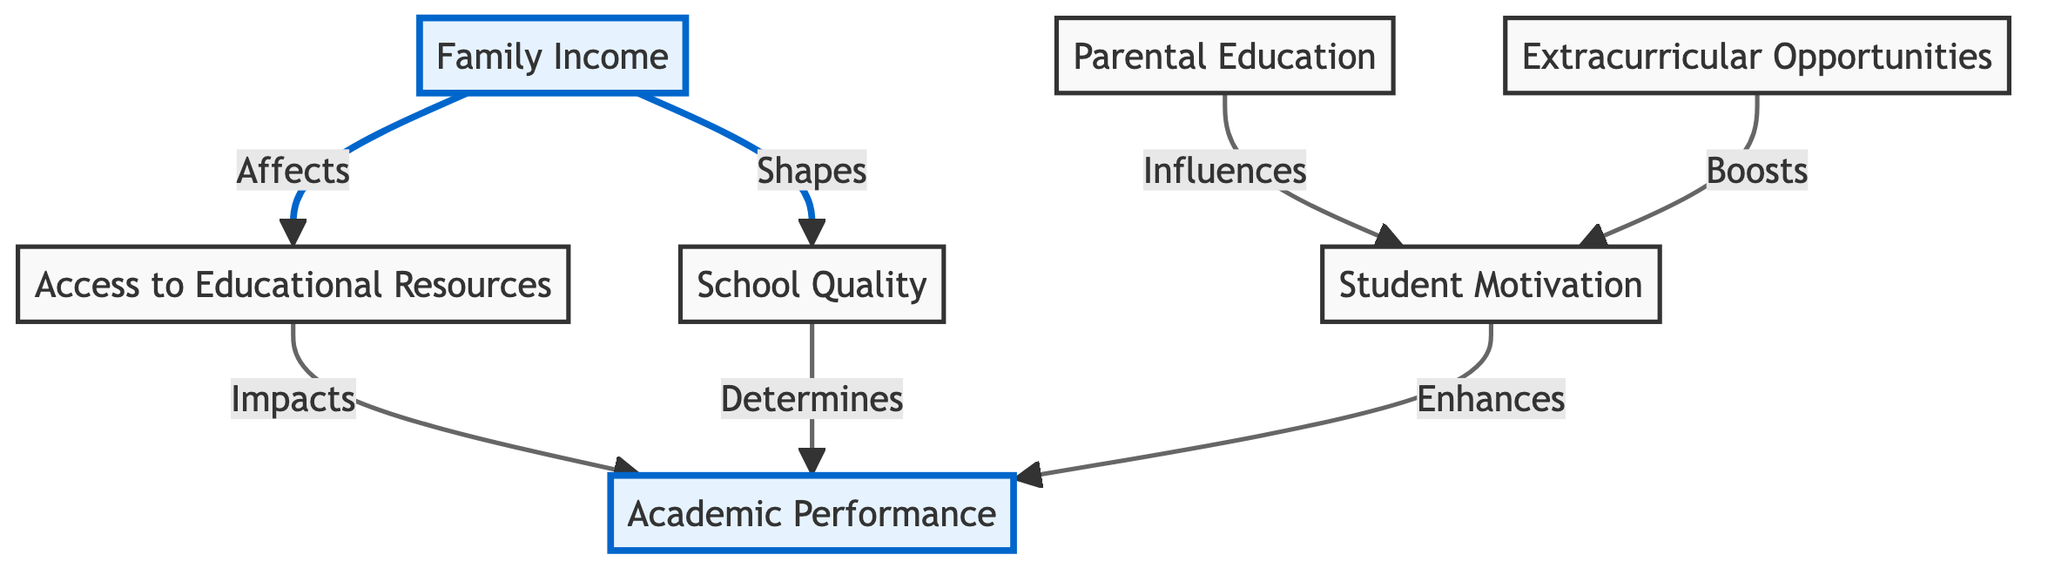What is the first node in the diagram? The first node in the diagram is "Family Income," which is represented at the top of the flowchart and highlighted.
Answer: Family Income How many nodes are present in the diagram? There are a total of six nodes in the diagram, including both highlighted and non-highlighted nodes.
Answer: Six Which node directly influences "Student Motivation"? "Parental Education" is the node that directly influences "Student Motivation," as indicated by the directional arrow connecting them.
Answer: Parental Education What is the relationship between "Family Income" and "School Quality"? "Family Income" shapes "School Quality," as depicted by the arrow showing the direct relationship from "Family Income" to "School Quality."
Answer: Shapes How does "Access to Educational Resources" impact "Academic Performance"? "Access to Educational Resources" has a direct impact on "Academic Performance," as shown by the arrow connecting these two nodes.
Answer: Impacts Which node boosts student motivation? "Extracurricular Opportunities" boosts student motivation, as indicated by the arrow linking it to "Student Motivation."
Answer: Extracurricular Opportunities How many edges are there in the diagram? There are six edges in the diagram that represent the relationships between the nodes.
Answer: Six Which node has the greatest direct influence on "Academic Performance"? The node "School Quality" has the greatest direct influence on "Academic Performance," as shown by the link between them.
Answer: School Quality What node comes before "Access to Educational Resources"? "Family Income" comes before "Access to Educational Resources," indicated by the arrow that flows into it.
Answer: Family Income 